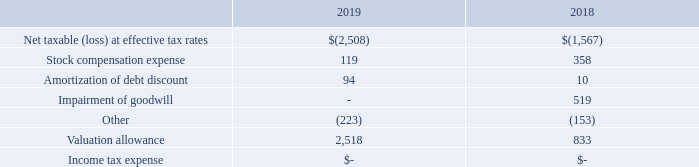13. INCOME TAXES
The Company files income tax returns in the U.S. federal jurisdiction and the state of California. With few exceptions, the Company is no longer subject to U.S. federal, state and local, or non-U.S. income tax examinations by tax authorities for years before 2015.
Deferred income taxes have been provided by temporary differences between the carrying amounts of assets and liabilities for financial reporting purposes and the amounts used for tax purposes. To the extent allowed by GAAP, the Company provides valuation allowances against the deferred tax assets for amounts when the realization is uncertain. Included in the balances at December 31, 2019 and 2018, are no tax positions for which the ultimate deductibility is highly certain, but for which there is uncertainty about the timing of such deductibility. Because of the impact of deferred tax accounting, other than interest and penalties, the disallowance of the shorter deductibility period would not affect the annual effective tax rate but would accelerate the payment of cash to the taxing authority to an earlier period.
The Company’s policy is to recognize interest accrued related to unrecognized tax benefits in interest expense and penalties in operating expenses. During the periods ended December 31, 2019 and 2018, the Company did not recognize interest and penalties.
The income tax provision differs from the amount of income tax determined by applying the U.S. federal income tax rate to pretax income from continuing operations for the year ended December 31, 2019 and 2018 due to the following:
What is the valuation allowance in 2019? 2,518. Where does the company file income tax returns? In the u.s. federal jurisdiction and the state of california. What is the net loss at effective tax rates in 2019? 2,508. What is the percentage change in the net loss at effective tax rates from 2018 to 2019?
Answer scale should be: percent. (2,508-1,567)/1,567
Answer: 60.05. What is the percentage change in the stock compensation expense from 2018 to 2019?
Answer scale should be: percent. (119-358)/358
Answer: -66.76. What is the percentage change in the valuation allowance from 2018 to 2019?
Answer scale should be: percent. (2,518-833)/833
Answer: 202.28. 